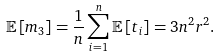<formula> <loc_0><loc_0><loc_500><loc_500>\mathbb { E } \left [ m _ { 3 } \right ] = \frac { 1 } { n } \sum _ { i = 1 } ^ { n } \mathbb { E } \left [ t _ { i } \right ] = 3 n ^ { 2 } r ^ { 2 } .</formula> 